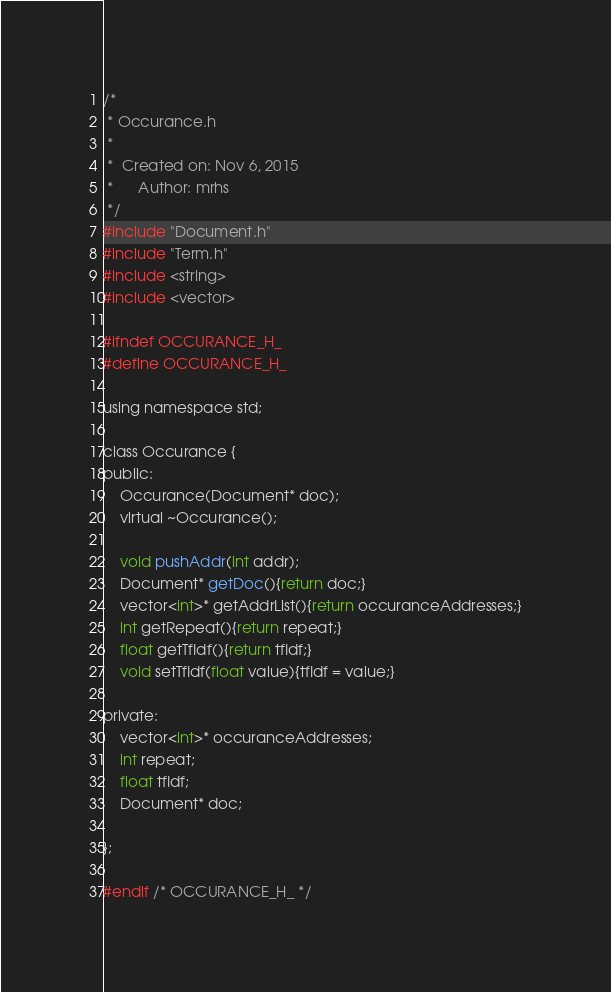Convert code to text. <code><loc_0><loc_0><loc_500><loc_500><_C_>/*
 * Occurance.h
 *
 *  Created on: Nov 6, 2015
 *      Author: mrhs
 */
#include "Document.h"
#include "Term.h"
#include <string>
#include <vector>

#ifndef OCCURANCE_H_
#define OCCURANCE_H_

using namespace std;

class Occurance {
public:
	Occurance(Document* doc);
	virtual ~Occurance();

	void pushAddr(int addr);
	Document* getDoc(){return doc;}
	vector<int>* getAddrList(){return occuranceAddresses;}
	int getRepeat(){return repeat;}
	float getTfIdf(){return tfIdf;}
	void setTfIdf(float value){tfIdf = value;}

private:
	vector<int>* occuranceAddresses;
	int repeat;
	float tfIdf;
	Document* doc;

};

#endif /* OCCURANCE_H_ */
</code> 